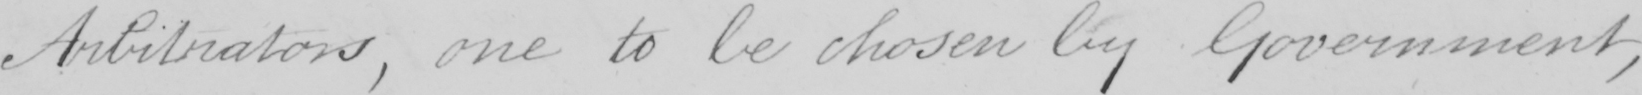What is written in this line of handwriting? Arbitrators , one to be chosen by Government , 